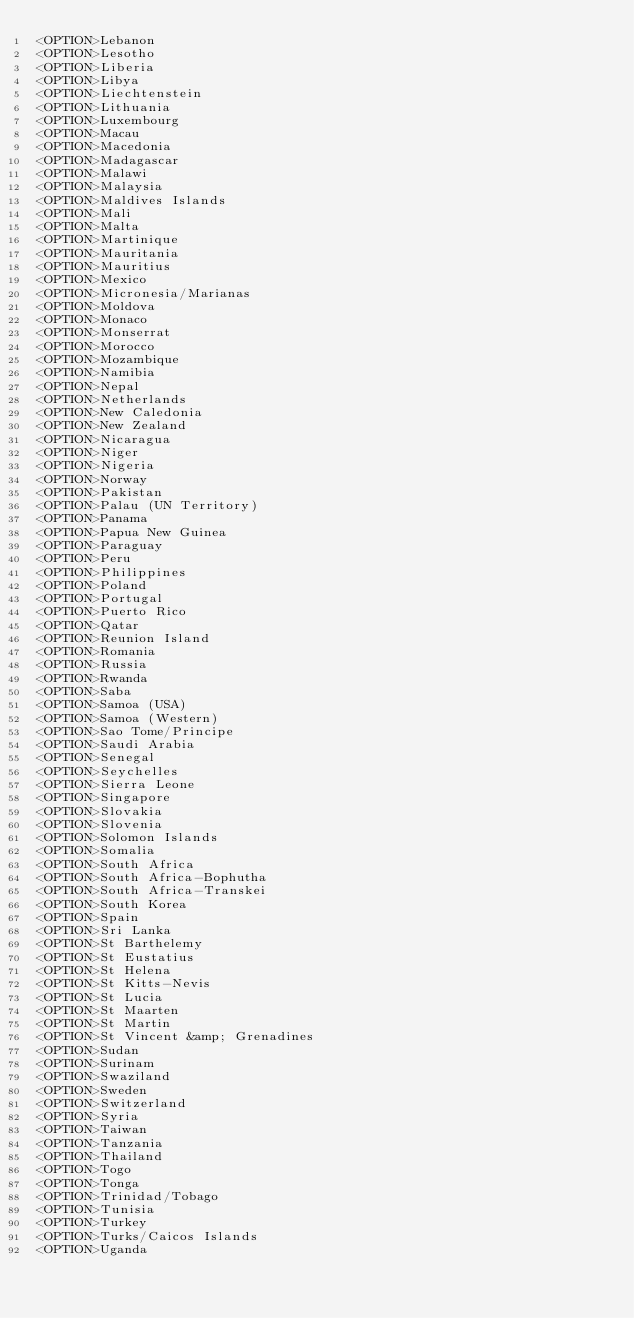<code> <loc_0><loc_0><loc_500><loc_500><_Perl_><OPTION>Lebanon
<OPTION>Lesotho
<OPTION>Liberia
<OPTION>Libya
<OPTION>Liechtenstein
<OPTION>Lithuania
<OPTION>Luxembourg
<OPTION>Macau
<OPTION>Macedonia
<OPTION>Madagascar
<OPTION>Malawi
<OPTION>Malaysia
<OPTION>Maldives Islands
<OPTION>Mali
<OPTION>Malta
<OPTION>Martinique
<OPTION>Mauritania
<OPTION>Mauritius
<OPTION>Mexico
<OPTION>Micronesia/Marianas
<OPTION>Moldova
<OPTION>Monaco
<OPTION>Monserrat
<OPTION>Morocco
<OPTION>Mozambique
<OPTION>Namibia
<OPTION>Nepal
<OPTION>Netherlands
<OPTION>New Caledonia
<OPTION>New Zealand
<OPTION>Nicaragua
<OPTION>Niger
<OPTION>Nigeria
<OPTION>Norway
<OPTION>Pakistan
<OPTION>Palau (UN Territory)
<OPTION>Panama
<OPTION>Papua New Guinea
<OPTION>Paraguay
<OPTION>Peru
<OPTION>Philippines
<OPTION>Poland
<OPTION>Portugal
<OPTION>Puerto Rico
<OPTION>Qatar
<OPTION>Reunion Island
<OPTION>Romania
<OPTION>Russia
<OPTION>Rwanda
<OPTION>Saba
<OPTION>Samoa (USA)
<OPTION>Samoa (Western)
<OPTION>Sao Tome/Principe
<OPTION>Saudi Arabia
<OPTION>Senegal
<OPTION>Seychelles
<OPTION>Sierra Leone
<OPTION>Singapore
<OPTION>Slovakia
<OPTION>Slovenia
<OPTION>Solomon Islands
<OPTION>Somalia
<OPTION>South Africa
<OPTION>South Africa-Bophutha
<OPTION>South Africa-Transkei
<OPTION>South Korea
<OPTION>Spain
<OPTION>Sri Lanka
<OPTION>St Barthelemy
<OPTION>St Eustatius
<OPTION>St Helena
<OPTION>St Kitts-Nevis
<OPTION>St Lucia
<OPTION>St Maarten
<OPTION>St Martin
<OPTION>St Vincent &amp; Grenadines
<OPTION>Sudan
<OPTION>Surinam
<OPTION>Swaziland
<OPTION>Sweden
<OPTION>Switzerland
<OPTION>Syria
<OPTION>Taiwan
<OPTION>Tanzania
<OPTION>Thailand
<OPTION>Togo
<OPTION>Tonga
<OPTION>Trinidad/Tobago
<OPTION>Tunisia
<OPTION>Turkey
<OPTION>Turks/Caicos Islands
<OPTION>Uganda</code> 